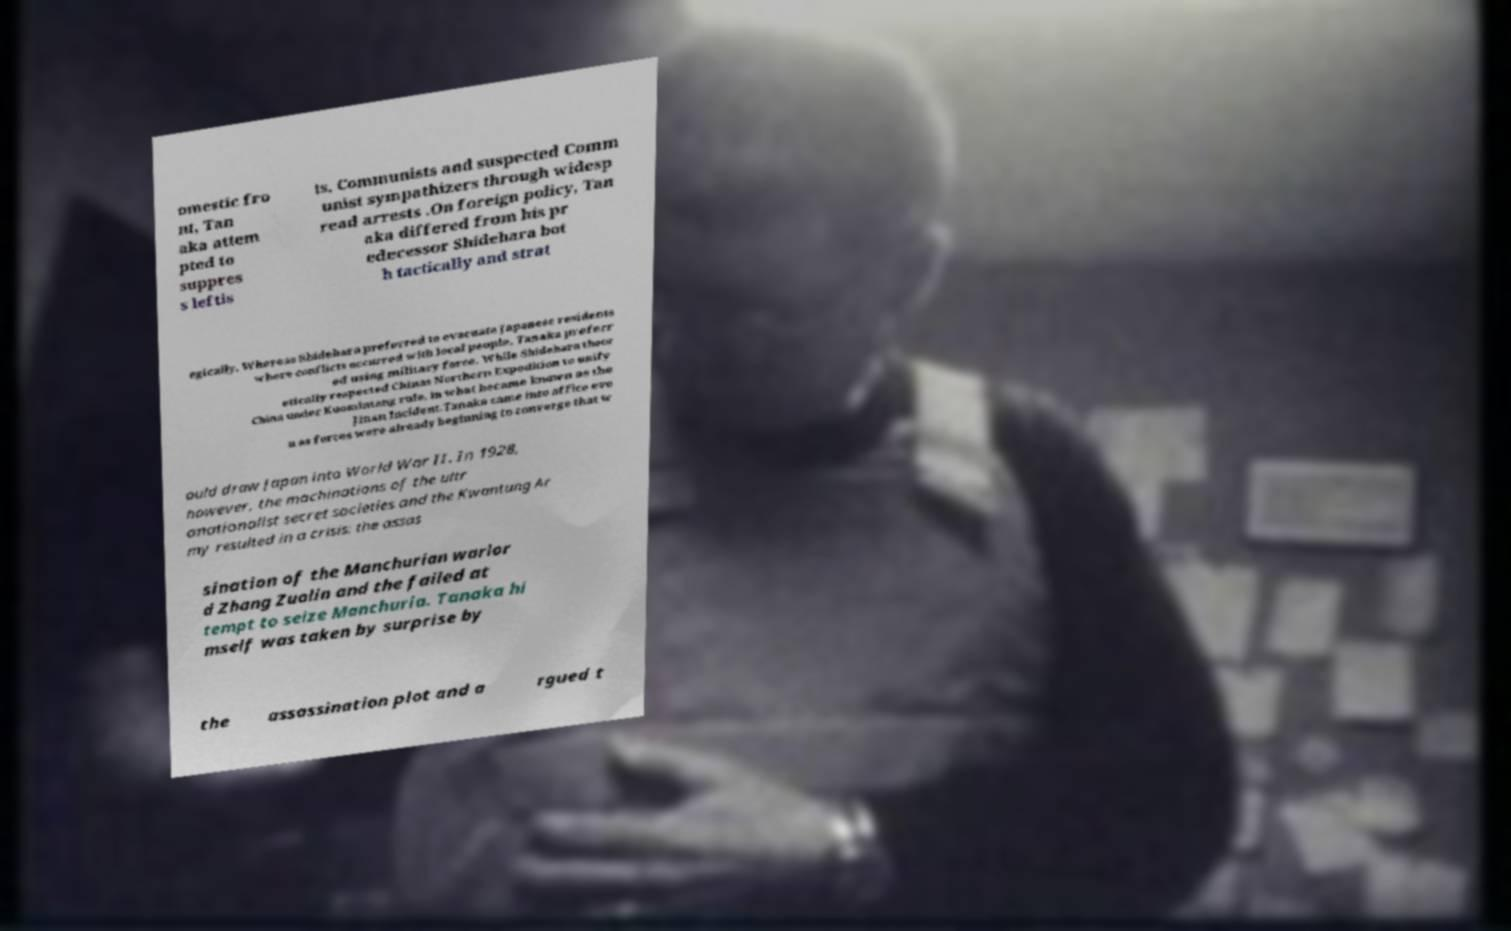What messages or text are displayed in this image? I need them in a readable, typed format. omestic fro nt, Tan aka attem pted to suppres s leftis ts, Communists and suspected Comm unist sympathizers through widesp read arrests .On foreign policy, Tan aka differed from his pr edecessor Shidehara bot h tactically and strat egically. Whereas Shidehara preferred to evacuate Japanese residents where conflicts occurred with local people, Tanaka preferr ed using military force. While Shidehara theor etically respected Chinas Northern Expedition to unify China under Kuomintang rule, in what became known as the Jinan Incident.Tanaka came into office eve n as forces were already beginning to converge that w ould draw Japan into World War II. In 1928, however, the machinations of the ultr anationalist secret societies and the Kwantung Ar my resulted in a crisis: the assas sination of the Manchurian warlor d Zhang Zuolin and the failed at tempt to seize Manchuria. Tanaka hi mself was taken by surprise by the assassination plot and a rgued t 